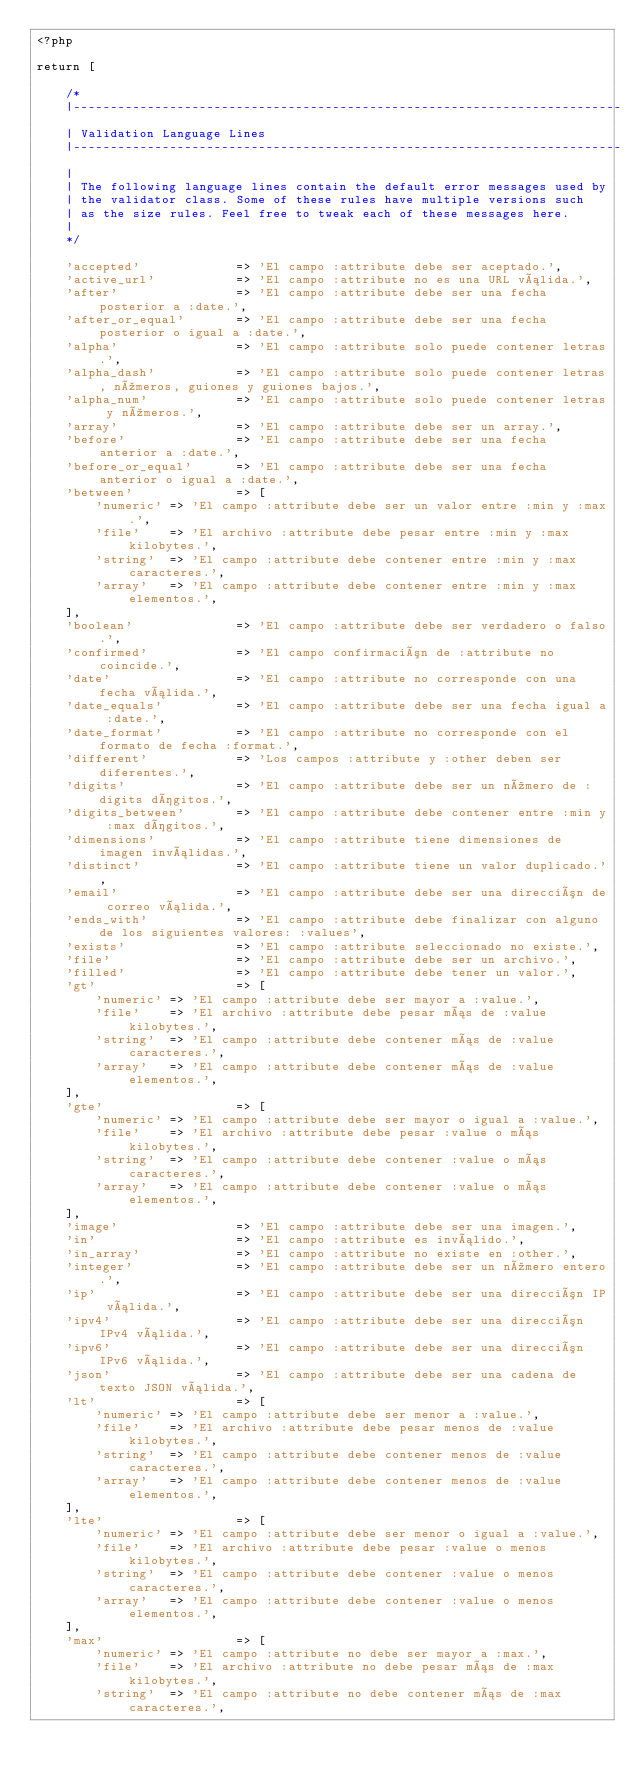Convert code to text. <code><loc_0><loc_0><loc_500><loc_500><_PHP_><?php

return [

    /*
    |--------------------------------------------------------------------------
    | Validation Language Lines
    |--------------------------------------------------------------------------
    |
    | The following language lines contain the default error messages used by
    | the validator class. Some of these rules have multiple versions such
    | as the size rules. Feel free to tweak each of these messages here.
    |
    */

    'accepted'             => 'El campo :attribute debe ser aceptado.',
    'active_url'           => 'El campo :attribute no es una URL válida.',
    'after'                => 'El campo :attribute debe ser una fecha posterior a :date.',
    'after_or_equal'       => 'El campo :attribute debe ser una fecha posterior o igual a :date.',
    'alpha'                => 'El campo :attribute solo puede contener letras.',
    'alpha_dash'           => 'El campo :attribute solo puede contener letras, números, guiones y guiones bajos.',
    'alpha_num'            => 'El campo :attribute solo puede contener letras y números.',
    'array'                => 'El campo :attribute debe ser un array.',
    'before'               => 'El campo :attribute debe ser una fecha anterior a :date.',
    'before_or_equal'      => 'El campo :attribute debe ser una fecha anterior o igual a :date.',
    'between'              => [
        'numeric' => 'El campo :attribute debe ser un valor entre :min y :max.',
        'file'    => 'El archivo :attribute debe pesar entre :min y :max kilobytes.',
        'string'  => 'El campo :attribute debe contener entre :min y :max caracteres.',
        'array'   => 'El campo :attribute debe contener entre :min y :max elementos.',
    ],
    'boolean'              => 'El campo :attribute debe ser verdadero o falso.',
    'confirmed'            => 'El campo confirmación de :attribute no coincide.',
    'date'                 => 'El campo :attribute no corresponde con una fecha válida.',
    'date_equals'          => 'El campo :attribute debe ser una fecha igual a :date.',
    'date_format'          => 'El campo :attribute no corresponde con el formato de fecha :format.',
    'different'            => 'Los campos :attribute y :other deben ser diferentes.',
    'digits'               => 'El campo :attribute debe ser un número de :digits dígitos.',
    'digits_between'       => 'El campo :attribute debe contener entre :min y :max dígitos.',
    'dimensions'           => 'El campo :attribute tiene dimensiones de imagen inválidas.',
    'distinct'             => 'El campo :attribute tiene un valor duplicado.',
    'email'                => 'El campo :attribute debe ser una dirección de correo válida.',
    'ends_with'            => 'El campo :attribute debe finalizar con alguno de los siguientes valores: :values',
    'exists'               => 'El campo :attribute seleccionado no existe.',
    'file'                 => 'El campo :attribute debe ser un archivo.',
    'filled'               => 'El campo :attribute debe tener un valor.',
    'gt'                   => [
        'numeric' => 'El campo :attribute debe ser mayor a :value.',
        'file'    => 'El archivo :attribute debe pesar más de :value kilobytes.',
        'string'  => 'El campo :attribute debe contener más de :value caracteres.',
        'array'   => 'El campo :attribute debe contener más de :value elementos.',
    ],
    'gte'                  => [
        'numeric' => 'El campo :attribute debe ser mayor o igual a :value.',
        'file'    => 'El archivo :attribute debe pesar :value o más kilobytes.',
        'string'  => 'El campo :attribute debe contener :value o más caracteres.',
        'array'   => 'El campo :attribute debe contener :value o más elementos.',
    ],
    'image'                => 'El campo :attribute debe ser una imagen.',
    'in'                   => 'El campo :attribute es inválido.',
    'in_array'             => 'El campo :attribute no existe en :other.',
    'integer'              => 'El campo :attribute debe ser un número entero.',
    'ip'                   => 'El campo :attribute debe ser una dirección IP válida.',
    'ipv4'                 => 'El campo :attribute debe ser una dirección IPv4 válida.',
    'ipv6'                 => 'El campo :attribute debe ser una dirección IPv6 válida.',
    'json'                 => 'El campo :attribute debe ser una cadena de texto JSON válida.',
    'lt'                   => [
        'numeric' => 'El campo :attribute debe ser menor a :value.',
        'file'    => 'El archivo :attribute debe pesar menos de :value kilobytes.',
        'string'  => 'El campo :attribute debe contener menos de :value caracteres.',
        'array'   => 'El campo :attribute debe contener menos de :value elementos.',
    ],
    'lte'                  => [
        'numeric' => 'El campo :attribute debe ser menor o igual a :value.',
        'file'    => 'El archivo :attribute debe pesar :value o menos kilobytes.',
        'string'  => 'El campo :attribute debe contener :value o menos caracteres.',
        'array'   => 'El campo :attribute debe contener :value o menos elementos.',
    ],
    'max'                  => [
        'numeric' => 'El campo :attribute no debe ser mayor a :max.',
        'file'    => 'El archivo :attribute no debe pesar más de :max kilobytes.',
        'string'  => 'El campo :attribute no debe contener más de :max caracteres.',</code> 